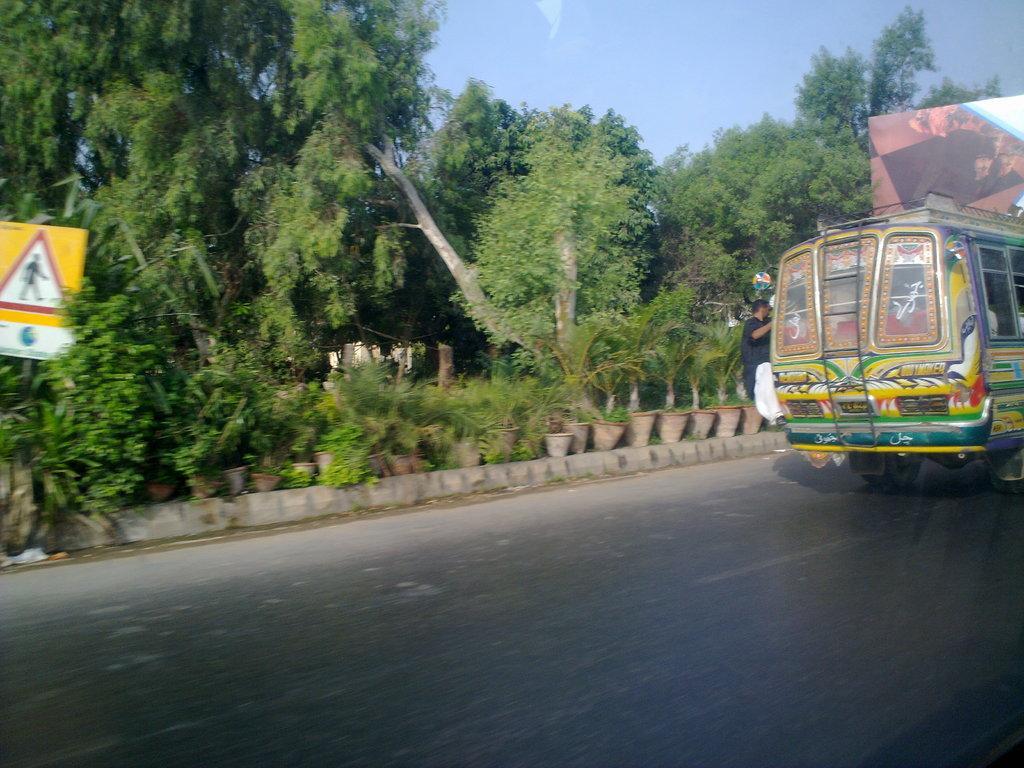Can you describe this image briefly? In the image we can see there is bus parked on the road and there is a person hanging to the bus. Beside there are lot of trees and there are plants kept on the pot. 